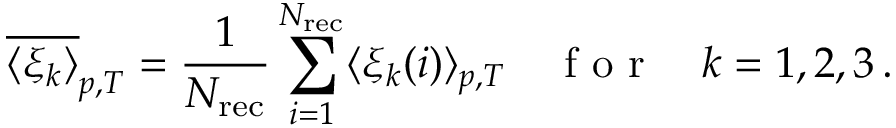<formula> <loc_0><loc_0><loc_500><loc_500>\overline { { \langle \xi _ { k } \rangle } } _ { p , T } = \frac { 1 } { N _ { r e c } } \sum _ { i = 1 } ^ { N _ { r e c } } \langle \xi _ { k } ( i ) \rangle _ { p , T } \quad f o r \quad k = 1 , 2 , 3 \, .</formula> 